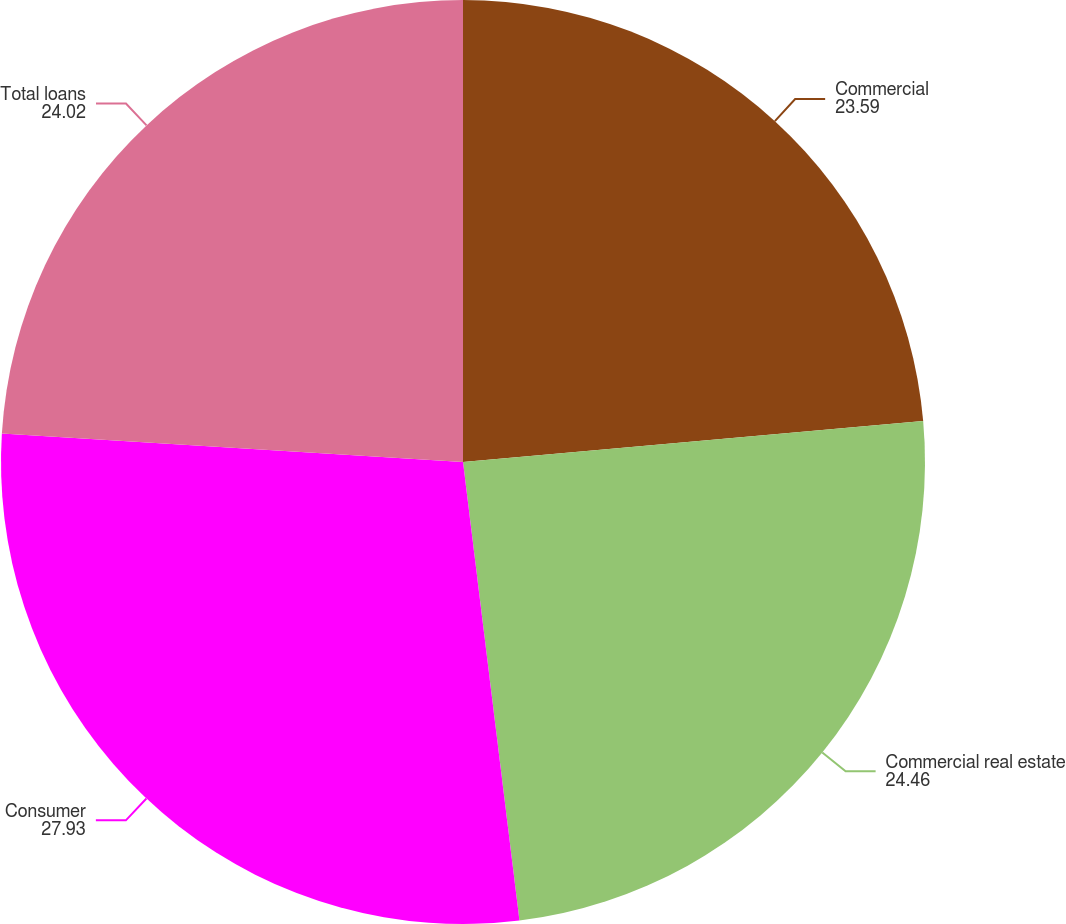Convert chart to OTSL. <chart><loc_0><loc_0><loc_500><loc_500><pie_chart><fcel>Commercial<fcel>Commercial real estate<fcel>Consumer<fcel>Total loans<nl><fcel>23.59%<fcel>24.46%<fcel>27.93%<fcel>24.02%<nl></chart> 